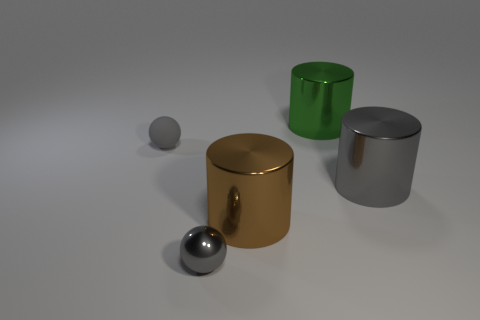Add 2 large brown shiny things. How many objects exist? 7 Subtract all cylinders. How many objects are left? 2 Subtract 0 red cubes. How many objects are left? 5 Subtract all big brown objects. Subtract all metal cylinders. How many objects are left? 1 Add 5 big green shiny objects. How many big green shiny objects are left? 6 Add 2 tiny gray balls. How many tiny gray balls exist? 4 